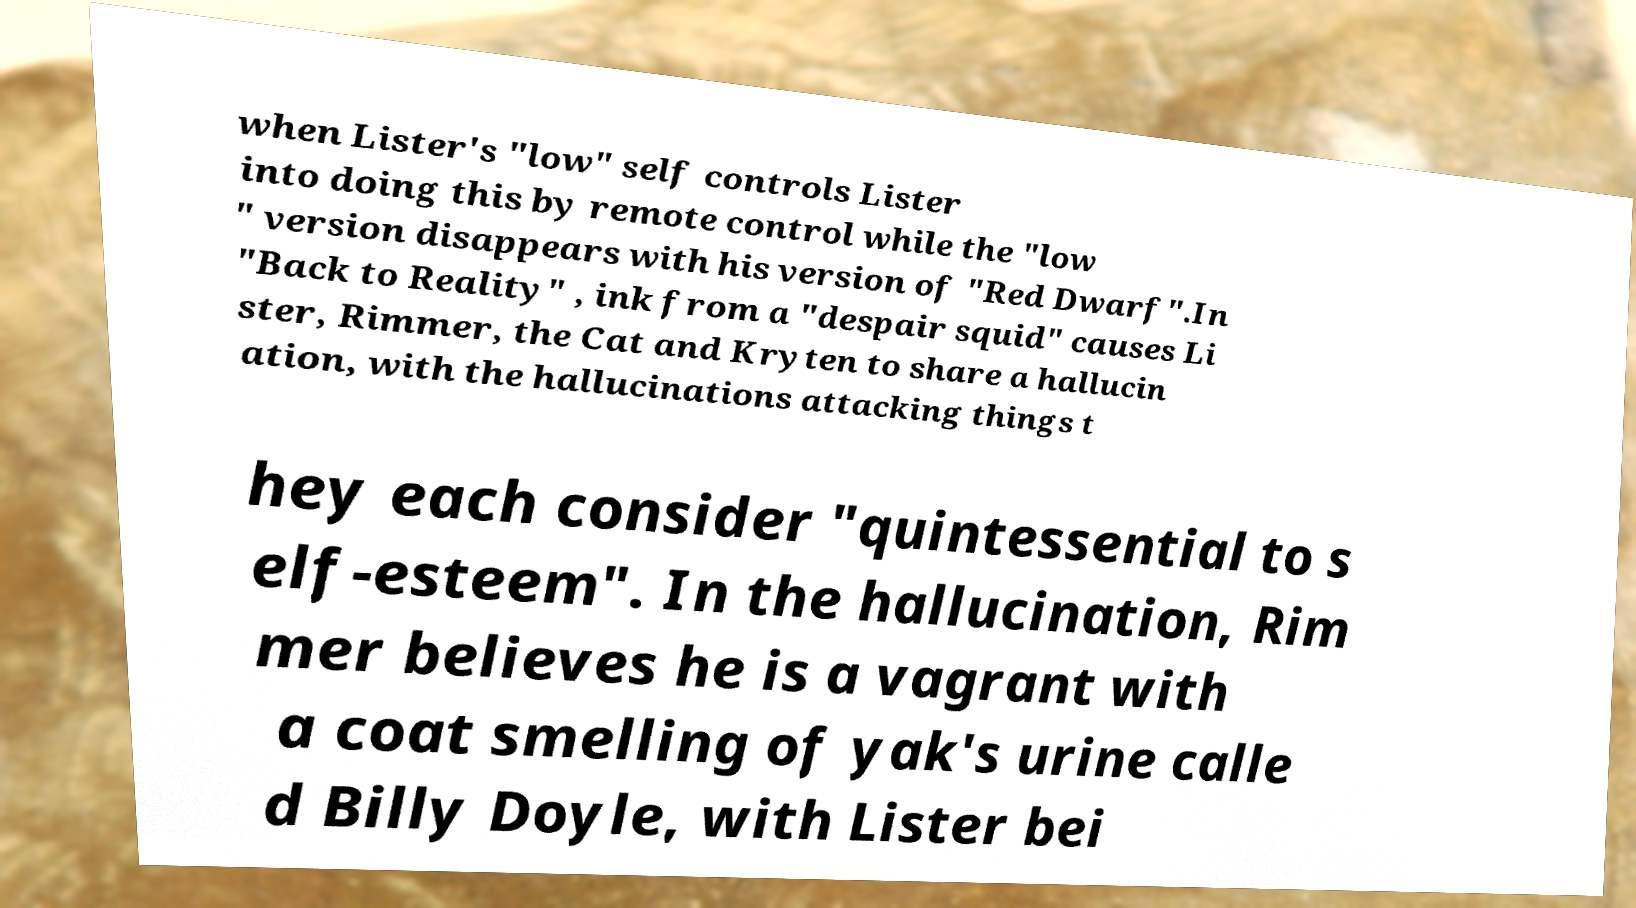Could you assist in decoding the text presented in this image and type it out clearly? when Lister's "low" self controls Lister into doing this by remote control while the "low " version disappears with his version of "Red Dwarf".In "Back to Reality" , ink from a "despair squid" causes Li ster, Rimmer, the Cat and Kryten to share a hallucin ation, with the hallucinations attacking things t hey each consider "quintessential to s elf-esteem". In the hallucination, Rim mer believes he is a vagrant with a coat smelling of yak's urine calle d Billy Doyle, with Lister bei 